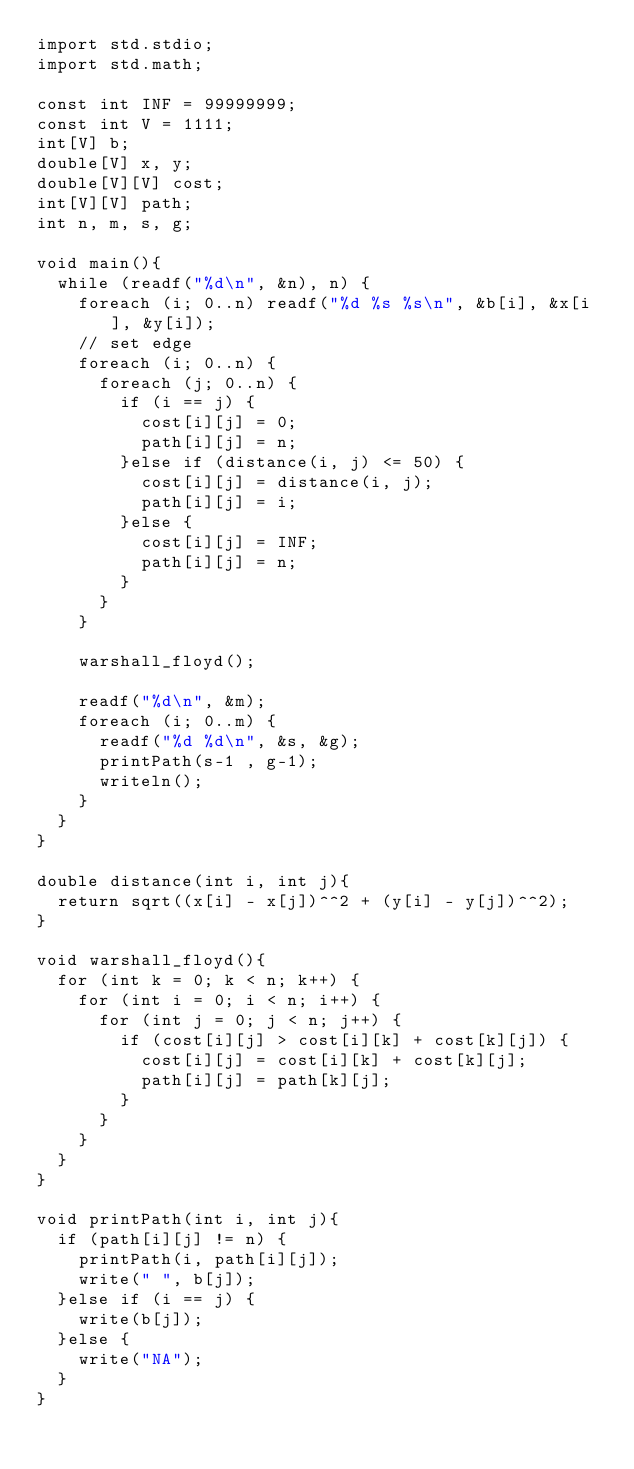<code> <loc_0><loc_0><loc_500><loc_500><_D_>import std.stdio;
import std.math;

const int INF = 99999999;
const int V = 1111;
int[V] b;
double[V] x, y;
double[V][V] cost;
int[V][V] path;
int n, m, s, g;

void main(){
	while (readf("%d\n", &n), n) {
		foreach (i; 0..n) readf("%d %s %s\n", &b[i], &x[i], &y[i]);
		// set edge
		foreach (i; 0..n) {
			foreach (j; 0..n) {
				if (i == j) {
					cost[i][j] = 0;
					path[i][j] = n;
				}else if (distance(i, j) <= 50) {
					cost[i][j] = distance(i, j);
					path[i][j] = i;
				}else {
					cost[i][j] = INF;
					path[i][j] = n;
				}
			}
		}
		
		warshall_floyd();

		readf("%d\n", &m);
		foreach (i; 0..m) {
			readf("%d %d\n", &s, &g);
			printPath(s-1 , g-1);
			writeln();
		}
	}
}

double distance(int i, int j){
	return sqrt((x[i] - x[j])^^2 + (y[i] - y[j])^^2);
}

void warshall_floyd(){
	for (int k = 0; k < n; k++) {
		for (int i = 0; i < n; i++) {
			for (int j = 0; j < n; j++) {
				if (cost[i][j] > cost[i][k] + cost[k][j]) {
					cost[i][j] = cost[i][k] + cost[k][j];
					path[i][j] = path[k][j];
				}
			}
		}
	}
}

void printPath(int i, int j){
	if (path[i][j] != n) {
		printPath(i, path[i][j]);
		write(" ", b[j]);
	}else if (i == j) {
		write(b[j]);
	}else {
		write("NA");
	}
}</code> 